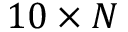Convert formula to latex. <formula><loc_0><loc_0><loc_500><loc_500>1 0 \times N</formula> 